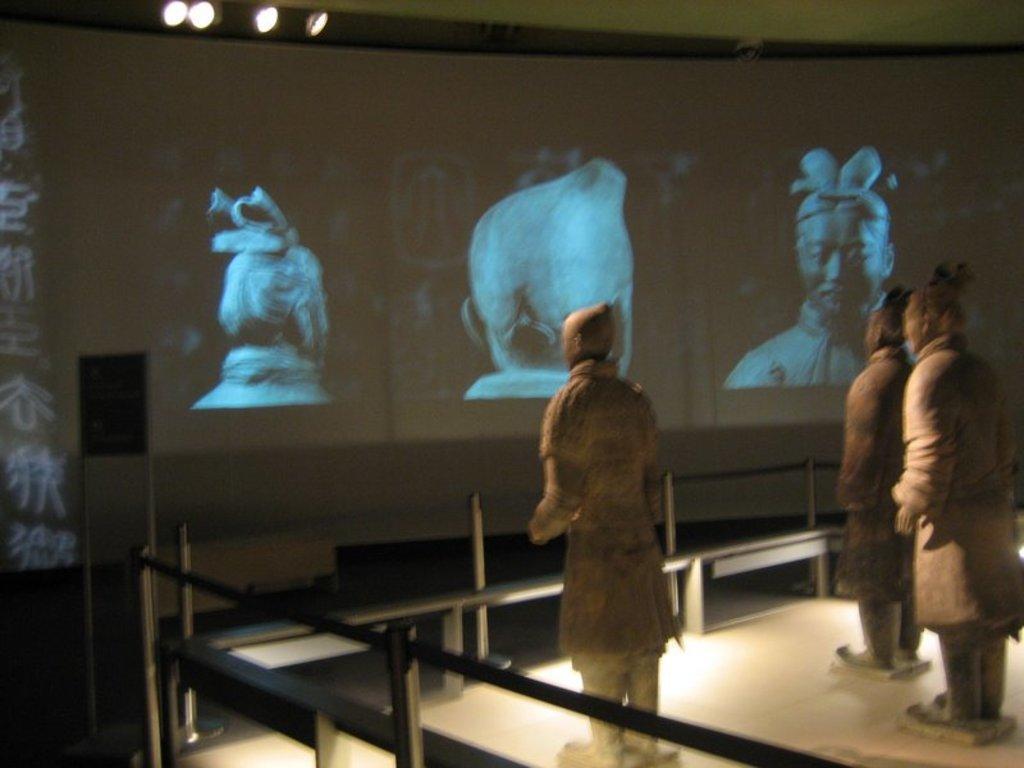Can you describe this image briefly? In the image there are statues on the floor. In front of them there are railings. In the background there is a screen with images and at the top of the image there are lights. 